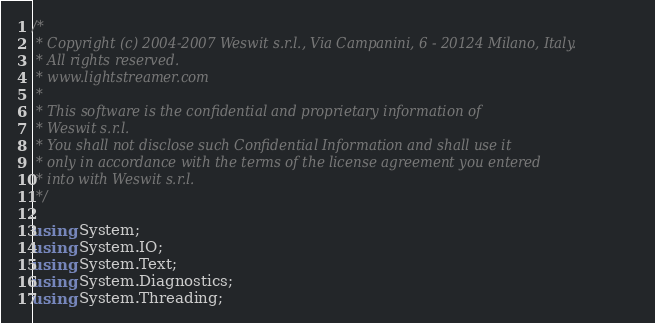<code> <loc_0><loc_0><loc_500><loc_500><_C#_>/*
 * Copyright (c) 2004-2007 Weswit s.r.l., Via Campanini, 6 - 20124 Milano, Italy.
 * All rights reserved.
 * www.lightstreamer.com
 *
 * This software is the confidential and proprietary information of
 * Weswit s.r.l.
 * You shall not disclose such Confidential Information and shall use it
 * only in accordance with the terms of the license agreement you entered
 * into with Weswit s.r.l.
 */

using System;
using System.IO;
using System.Text;
using System.Diagnostics;
using System.Threading;</code> 